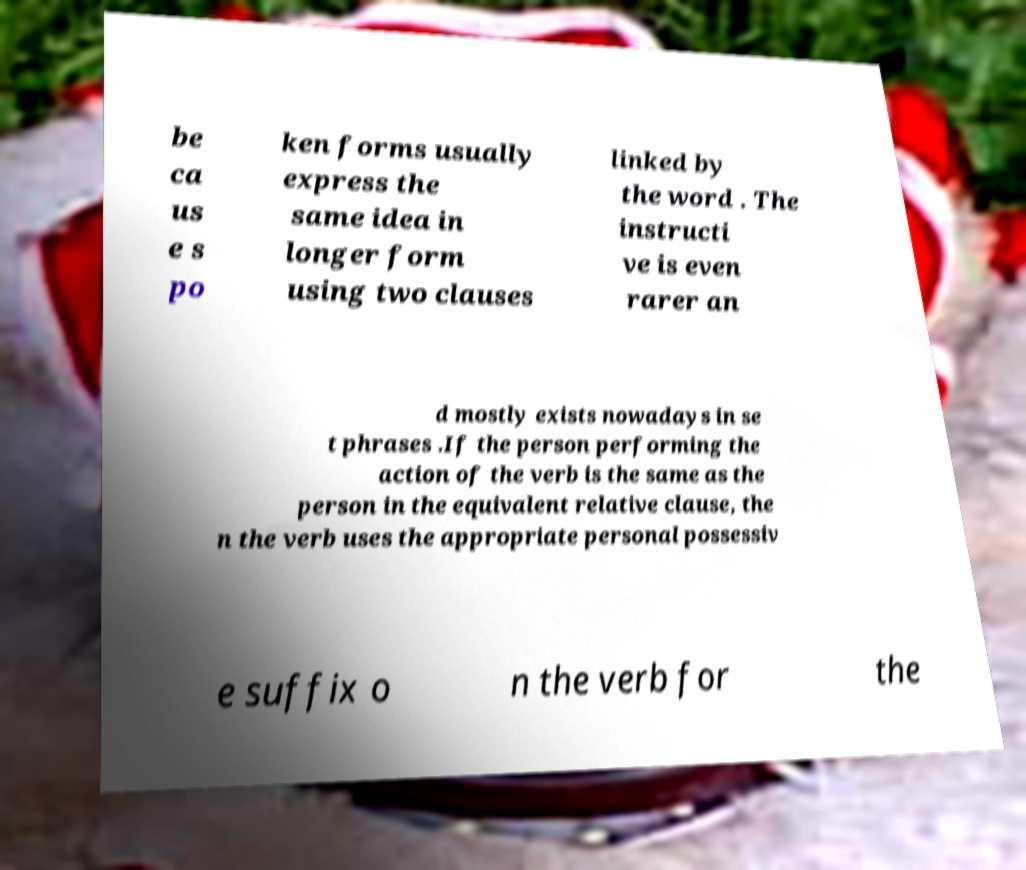For documentation purposes, I need the text within this image transcribed. Could you provide that? be ca us e s po ken forms usually express the same idea in longer form using two clauses linked by the word . The instructi ve is even rarer an d mostly exists nowadays in se t phrases .If the person performing the action of the verb is the same as the person in the equivalent relative clause, the n the verb uses the appropriate personal possessiv e suffix o n the verb for the 